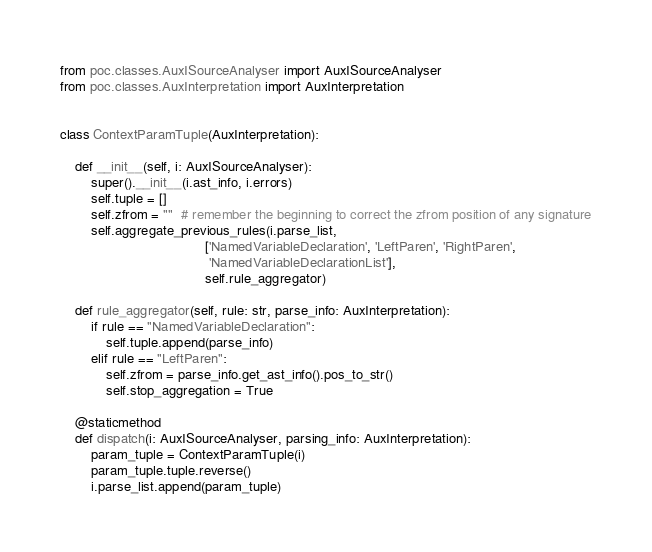Convert code to text. <code><loc_0><loc_0><loc_500><loc_500><_Python_>from poc.classes.AuxISourceAnalyser import AuxISourceAnalyser
from poc.classes.AuxInterpretation import AuxInterpretation


class ContextParamTuple(AuxInterpretation):

    def __init__(self, i: AuxISourceAnalyser):
        super().__init__(i.ast_info, i.errors)
        self.tuple = []
        self.zfrom = ""  # remember the beginning to correct the zfrom position of any signature
        self.aggregate_previous_rules(i.parse_list,
                                      ['NamedVariableDeclaration', 'LeftParen', 'RightParen',
                                       'NamedVariableDeclarationList'],
                                      self.rule_aggregator)

    def rule_aggregator(self, rule: str, parse_info: AuxInterpretation):
        if rule == "NamedVariableDeclaration":
            self.tuple.append(parse_info)
        elif rule == "LeftParen":
            self.zfrom = parse_info.get_ast_info().pos_to_str()
            self.stop_aggregation = True

    @staticmethod
    def dispatch(i: AuxISourceAnalyser, parsing_info: AuxInterpretation):
        param_tuple = ContextParamTuple(i)
        param_tuple.tuple.reverse()
        i.parse_list.append(param_tuple)

</code> 